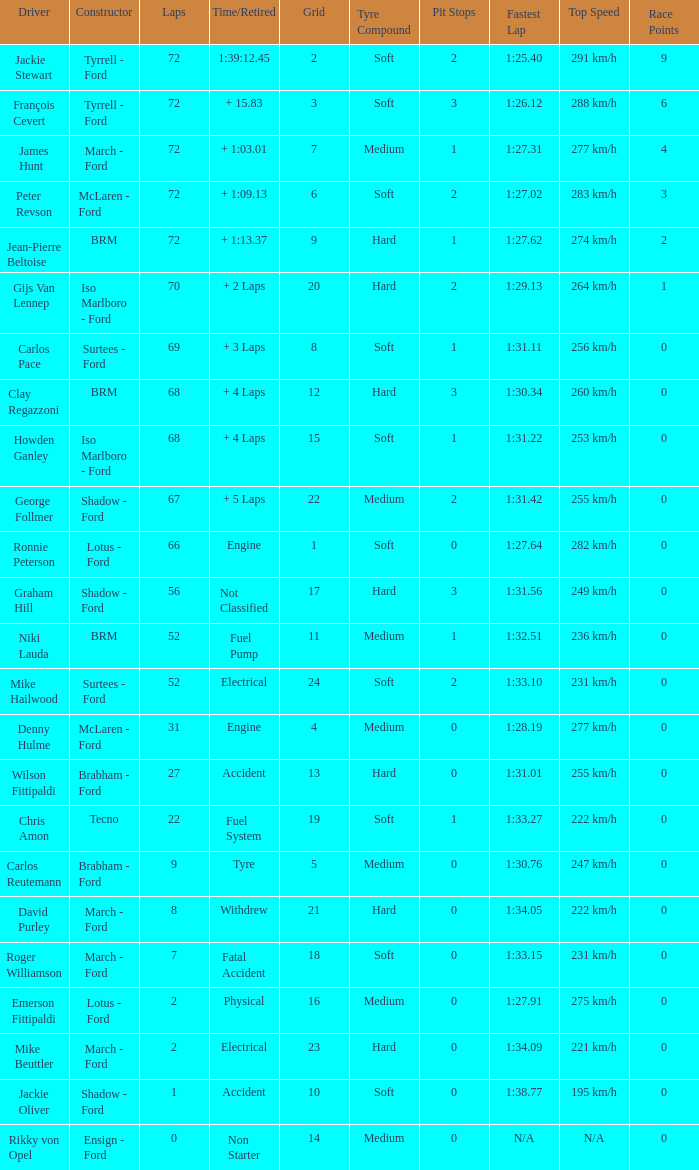What is the top grid that laps less than 66 and a retried engine? 4.0. 